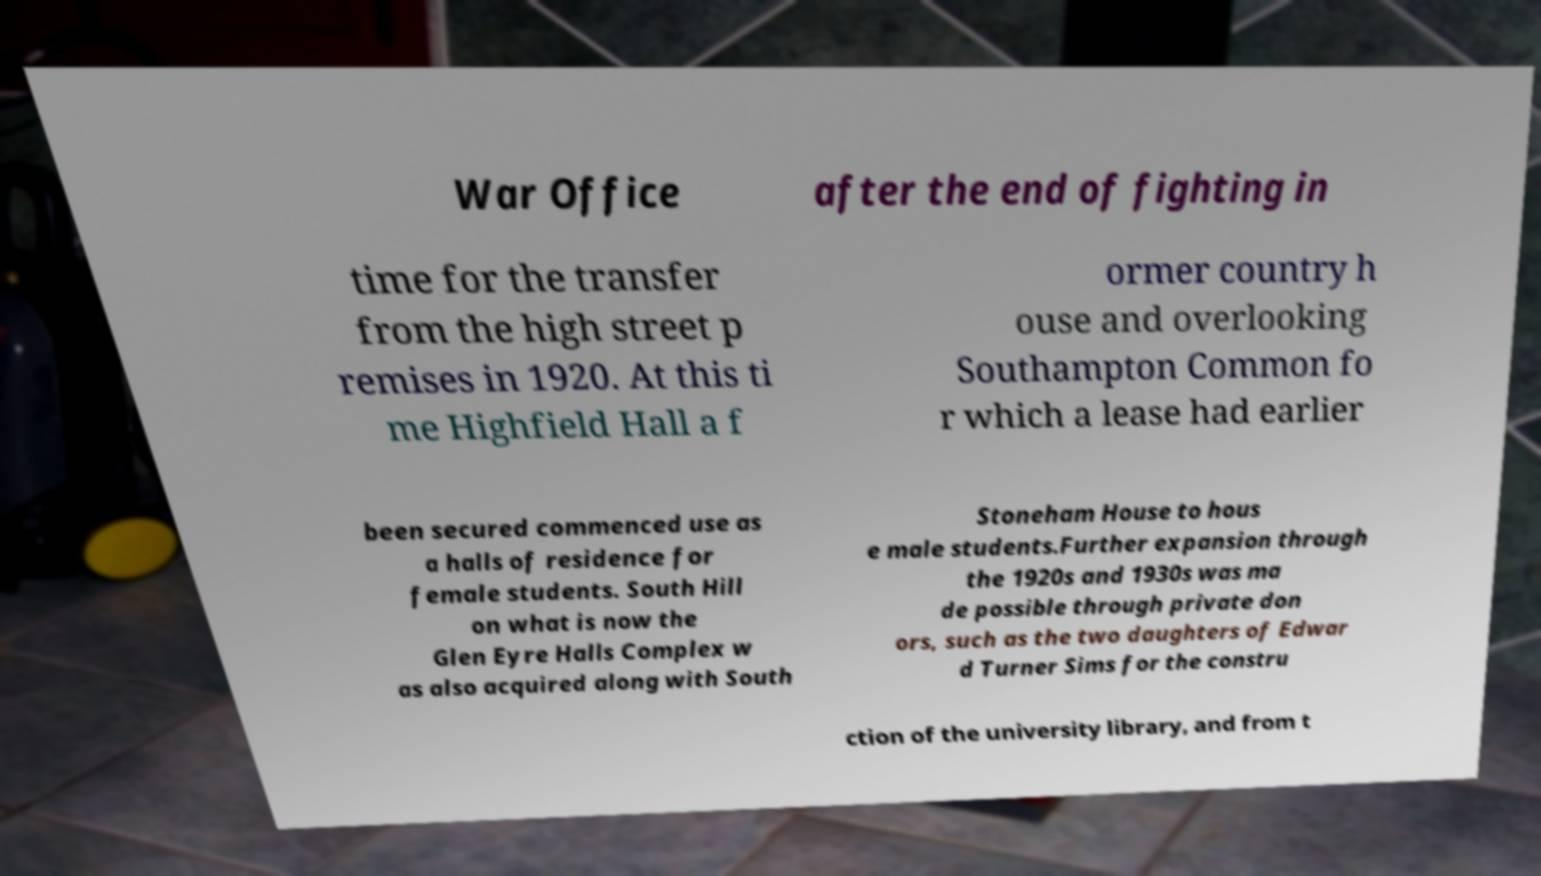Could you assist in decoding the text presented in this image and type it out clearly? War Office after the end of fighting in time for the transfer from the high street p remises in 1920. At this ti me Highfield Hall a f ormer country h ouse and overlooking Southampton Common fo r which a lease had earlier been secured commenced use as a halls of residence for female students. South Hill on what is now the Glen Eyre Halls Complex w as also acquired along with South Stoneham House to hous e male students.Further expansion through the 1920s and 1930s was ma de possible through private don ors, such as the two daughters of Edwar d Turner Sims for the constru ction of the university library, and from t 